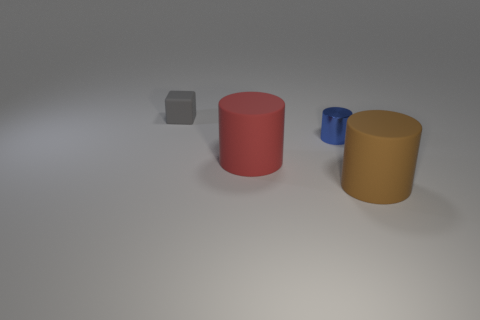Subtract all cyan cubes. Subtract all cyan balls. How many cubes are left? 1 Add 4 matte balls. How many objects exist? 8 Subtract all blocks. How many objects are left? 3 Add 1 big cyan objects. How many big cyan objects exist? 1 Subtract 0 purple blocks. How many objects are left? 4 Subtract all gray blocks. Subtract all big red matte cylinders. How many objects are left? 2 Add 3 big things. How many big things are left? 5 